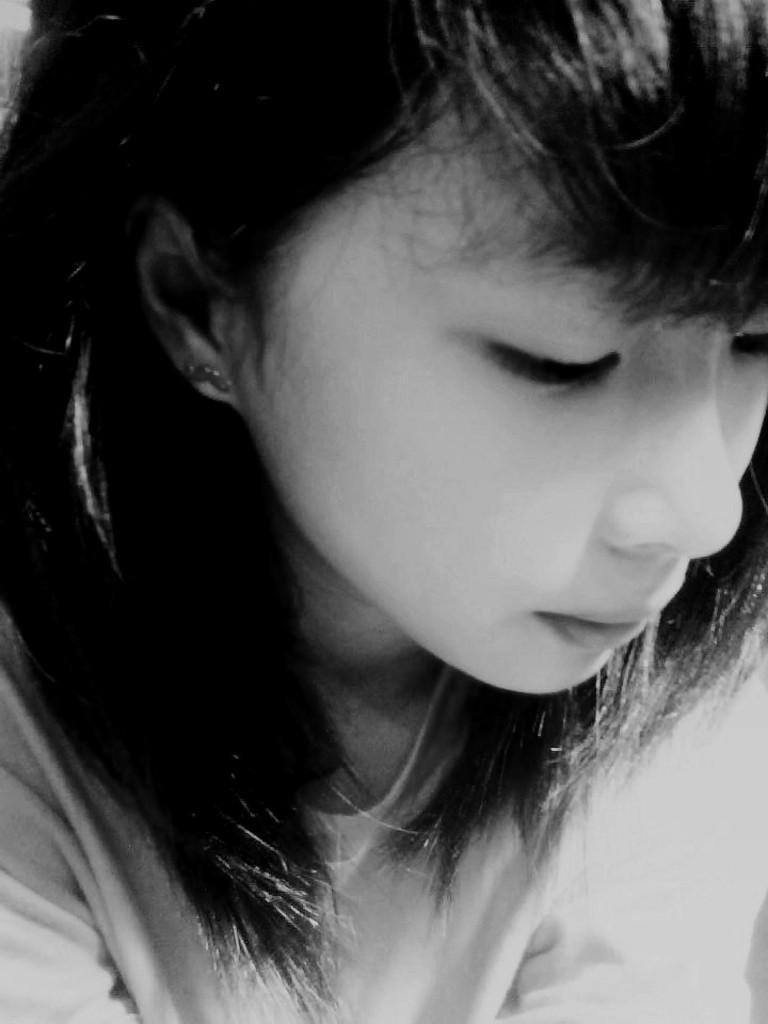Please provide a concise description of this image. In this Image I can see the person wearing the dress and this is black and white image. 